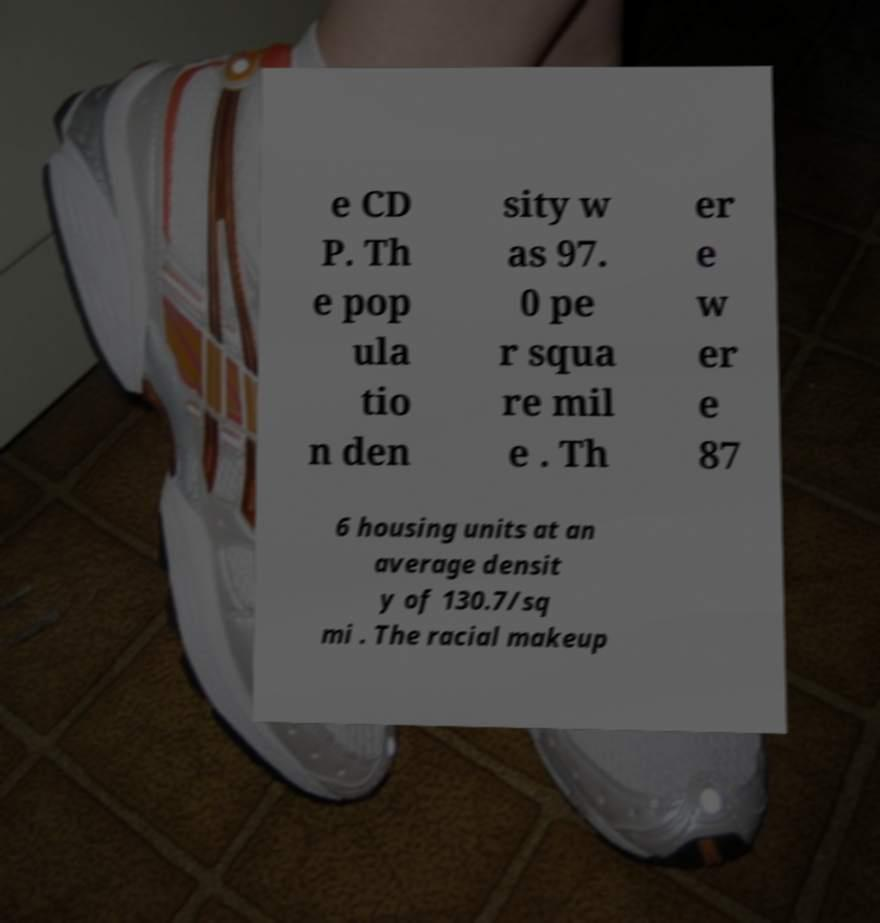For documentation purposes, I need the text within this image transcribed. Could you provide that? e CD P. Th e pop ula tio n den sity w as 97. 0 pe r squa re mil e . Th er e w er e 87 6 housing units at an average densit y of 130.7/sq mi . The racial makeup 